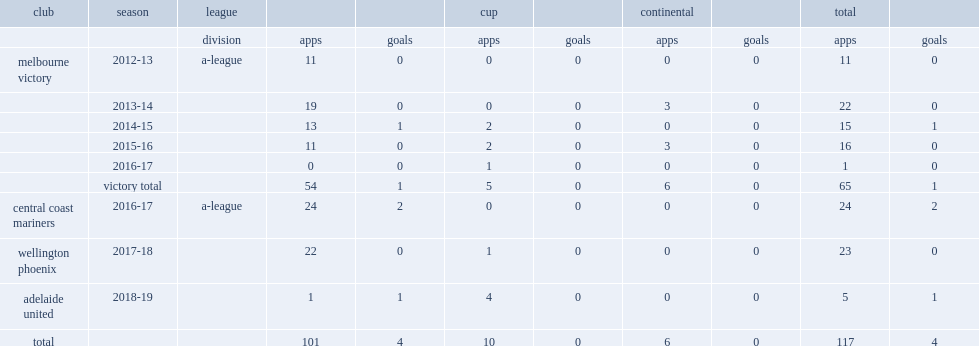Which club did galloway sign for a-league in the 2018-19 season? Adelaide united. I'm looking to parse the entire table for insights. Could you assist me with that? {'header': ['club', 'season', 'league', '', '', 'cup', '', 'continental', '', 'total', ''], 'rows': [['', '', 'division', 'apps', 'goals', 'apps', 'goals', 'apps', 'goals', 'apps', 'goals'], ['melbourne victory', '2012-13', 'a-league', '11', '0', '0', '0', '0', '0', '11', '0'], ['', '2013-14', '', '19', '0', '0', '0', '3', '0', '22', '0'], ['', '2014-15', '', '13', '1', '2', '0', '0', '0', '15', '1'], ['', '2015-16', '', '11', '0', '2', '0', '3', '0', '16', '0'], ['', '2016-17', '', '0', '0', '1', '0', '0', '0', '1', '0'], ['', 'victory total', '', '54', '1', '5', '0', '6', '0', '65', '1'], ['central coast mariners', '2016-17', 'a-league', '24', '2', '0', '0', '0', '0', '24', '2'], ['wellington phoenix', '2017-18', '', '22', '0', '1', '0', '0', '0', '23', '0'], ['adelaide united', '2018-19', '', '1', '1', '4', '0', '0', '0', '5', '1'], ['total', '', '', '101', '4', '10', '0', '6', '0', '117', '4']]} 